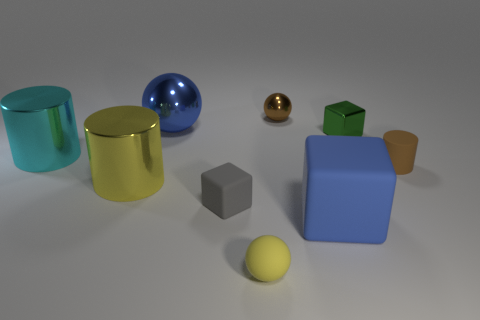Subtract all tiny yellow matte balls. How many balls are left? 2 Subtract all green blocks. How many blocks are left? 2 Add 1 tiny cyan rubber balls. How many objects exist? 10 Subtract all balls. How many objects are left? 6 Subtract 3 blocks. How many blocks are left? 0 Subtract 0 cyan cubes. How many objects are left? 9 Subtract all green cylinders. Subtract all red balls. How many cylinders are left? 3 Subtract all blue cubes. How many yellow cylinders are left? 1 Subtract all yellow shiny things. Subtract all small shiny blocks. How many objects are left? 7 Add 1 big cyan cylinders. How many big cyan cylinders are left? 2 